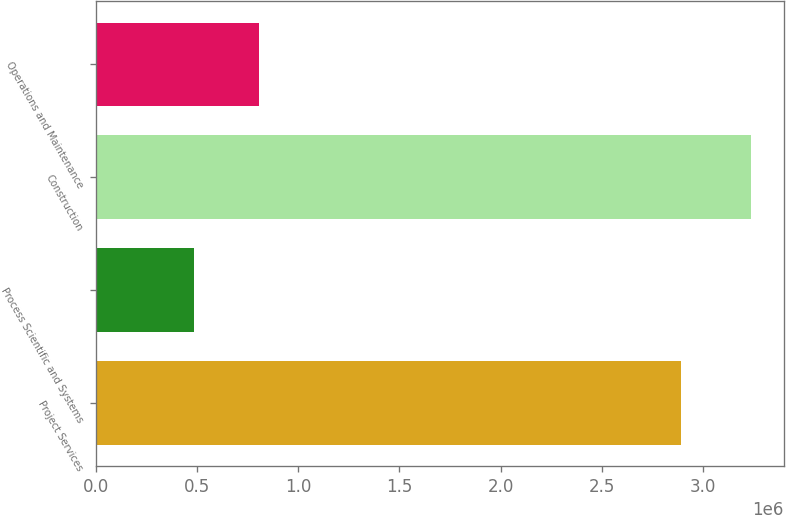Convert chart. <chart><loc_0><loc_0><loc_500><loc_500><bar_chart><fcel>Project Services<fcel>Process Scientific and Systems<fcel>Construction<fcel>Operations and Maintenance<nl><fcel>2.89429e+06<fcel>482344<fcel>3.23961e+06<fcel>805020<nl></chart> 